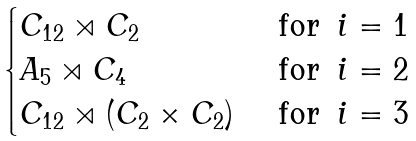<formula> <loc_0><loc_0><loc_500><loc_500>\begin{cases} C _ { 1 2 } \rtimes C _ { 2 } & \text { for } \, i = 1 \\ A _ { 5 } \rtimes C _ { 4 } & \text { for } \, i = 2 \\ C _ { 1 2 } \rtimes ( C _ { 2 } \times C _ { 2 } ) & \text { for } \, i = 3 \end{cases}</formula> 